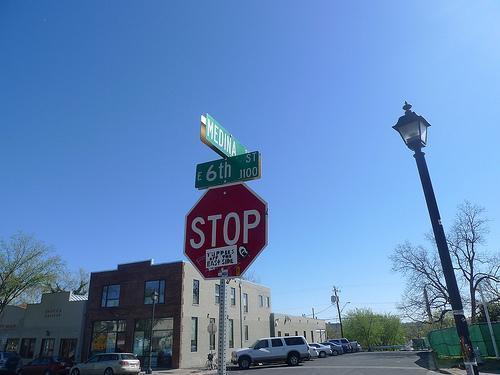How many green signs are there?
Give a very brief answer. 2. 